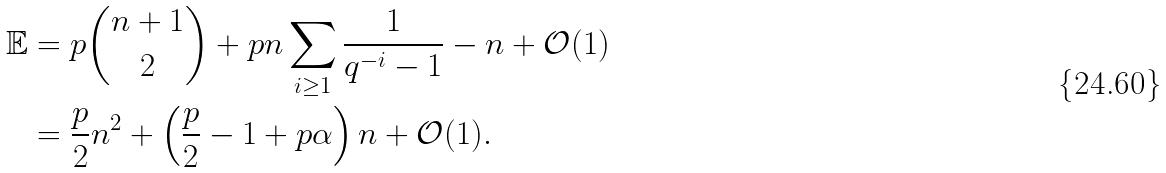<formula> <loc_0><loc_0><loc_500><loc_500>\mathbb { E } & = p \binom { n + 1 } { 2 } + p n \sum _ { i \geq 1 } \frac { 1 } { q ^ { - i } - 1 } - n + \mathcal { O } ( 1 ) \\ & = \frac { p } { 2 } n ^ { 2 } + \left ( \frac { p } { 2 } - 1 + p \alpha \right ) n + \mathcal { O } ( 1 ) .</formula> 